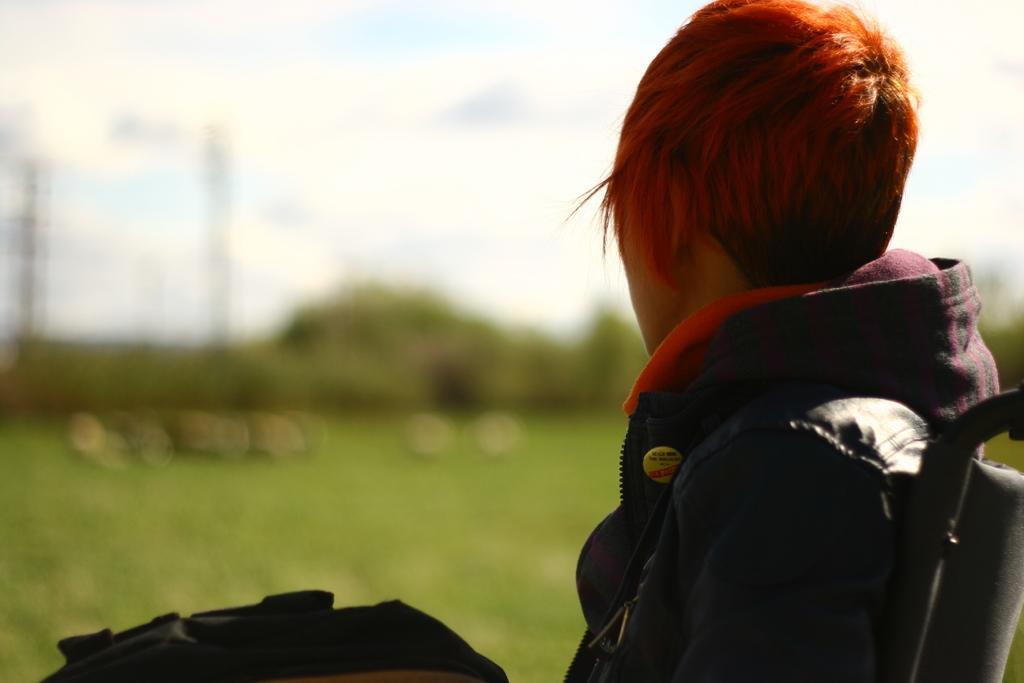Please provide a concise description of this image. In this picture I can observe a person wearing black color jacket. I can observe an orange color hair. In the background there are trees and a sky with some clouds. The background is partially blurred. 